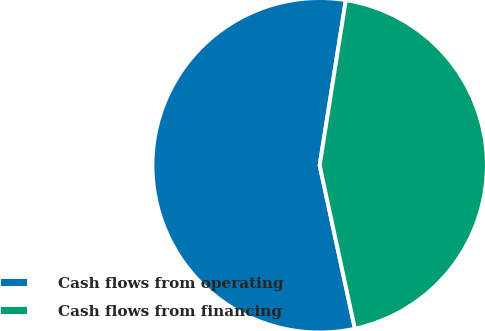Convert chart to OTSL. <chart><loc_0><loc_0><loc_500><loc_500><pie_chart><fcel>Cash flows from operating<fcel>Cash flows from financing<nl><fcel>55.88%<fcel>44.12%<nl></chart> 